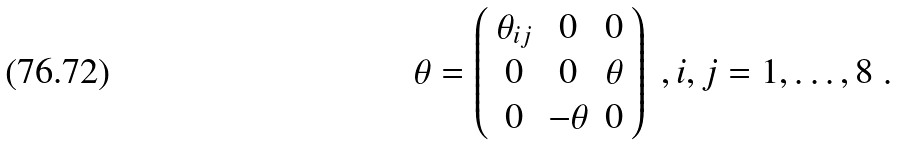Convert formula to latex. <formula><loc_0><loc_0><loc_500><loc_500>\theta = \left ( \begin{array} { c c c } \theta _ { i j } & 0 & 0 \\ 0 & 0 & \theta \\ 0 & - \theta & 0 \\ \end{array} \right ) \ , i , j = 1 , \dots , 8 \ .</formula> 